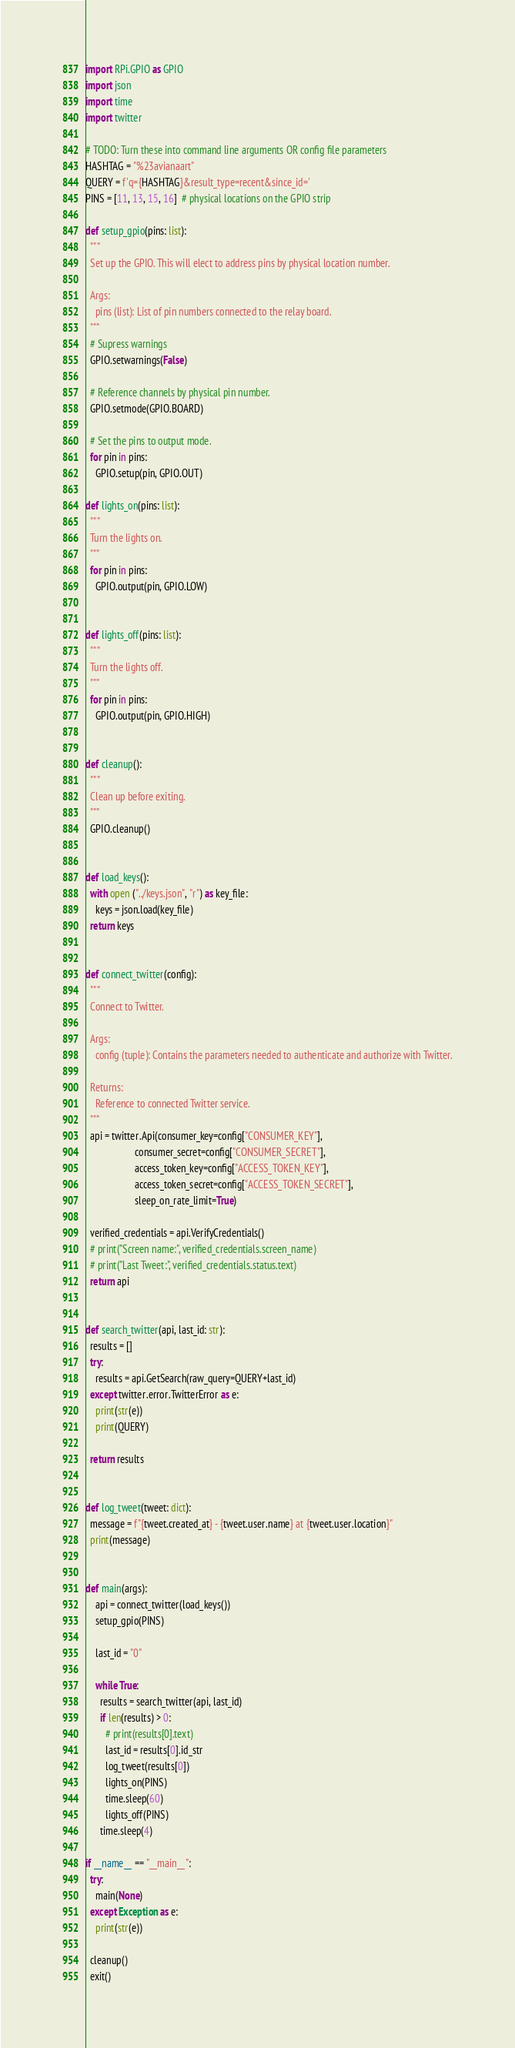Convert code to text. <code><loc_0><loc_0><loc_500><loc_500><_Python_>import RPi.GPIO as GPIO
import json
import time
import twitter

# TODO: Turn these into command line arguments OR config file parameters
HASHTAG = "%23avianaart"
QUERY = f'q={HASHTAG}&result_type=recent&since_id='
PINS = [11, 13, 15, 16]  # physical locations on the GPIO strip

def setup_gpio(pins: list):
  """
  Set up the GPIO. This will elect to address pins by physical location number.
  
  Args:
    pins (list): List of pin numbers connected to the relay board.
  """
  # Supress warnings
  GPIO.setwarnings(False)
  
  # Reference channels by physical pin number.
  GPIO.setmode(GPIO.BOARD)
  
  # Set the pins to output mode.
  for pin in pins:
    GPIO.setup(pin, GPIO.OUT)

def lights_on(pins: list):
  """
  Turn the lights on.
  """
  for pin in pins:
    GPIO.output(pin, GPIO.LOW)


def lights_off(pins: list):
  """
  Turn the lights off.
  """
  for pin in pins:
    GPIO.output(pin, GPIO.HIGH)


def cleanup():
  """
  Clean up before exiting.
  """
  GPIO.cleanup()


def load_keys():
  with open ("../keys.json", "r") as key_file:
    keys = json.load(key_file)
  return keys


def connect_twitter(config):
  """
  Connect to Twitter.
  
  Args:
    config (tuple): Contains the parameters needed to authenticate and authorize with Twitter.

  Returns:
    Reference to connected Twitter service.
  """
  api = twitter.Api(consumer_key=config["CONSUMER_KEY"],
                    consumer_secret=config["CONSUMER_SECRET"],
                    access_token_key=config["ACCESS_TOKEN_KEY"],
                    access_token_secret=config["ACCESS_TOKEN_SECRET"],
                    sleep_on_rate_limit=True)

  verified_credentials = api.VerifyCredentials()
  # print("Screen name:", verified_credentials.screen_name)
  # print("Last Tweet:", verified_credentials.status.text)
  return api


def search_twitter(api, last_id: str):
  results = []
  try:
    results = api.GetSearch(raw_query=QUERY+last_id)
  except twitter.error.TwitterError as e:
    print(str(e))
    print(QUERY)

  return results


def log_tweet(tweet: dict):
  message = f"{tweet.created_at} - {tweet.user.name} at {tweet.user.location}"
  print(message)


def main(args):
    api = connect_twitter(load_keys())
    setup_gpio(PINS)
    
    last_id = "0"

    while True:
      results = search_twitter(api, last_id)
      if len(results) > 0:
        # print(results[0].text)
        last_id = results[0].id_str
        log_tweet(results[0])
        lights_on(PINS)
        time.sleep(60)
        lights_off(PINS)
      time.sleep(4)

if __name__ == "__main__":
  try:
    main(None)
  except Exception as e:
    print(str(e))
    
  cleanup()
  exit()
</code> 